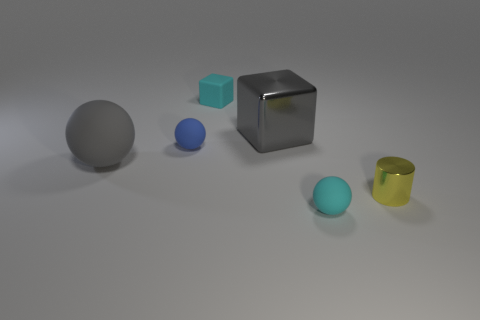Subtract all tiny rubber spheres. How many spheres are left? 1 Add 3 brown rubber blocks. How many objects exist? 9 Subtract all blocks. How many objects are left? 4 Subtract all tiny cyan rubber cubes. Subtract all large purple metal blocks. How many objects are left? 5 Add 4 large gray things. How many large gray things are left? 6 Add 5 large gray balls. How many large gray balls exist? 6 Subtract 0 blue cylinders. How many objects are left? 6 